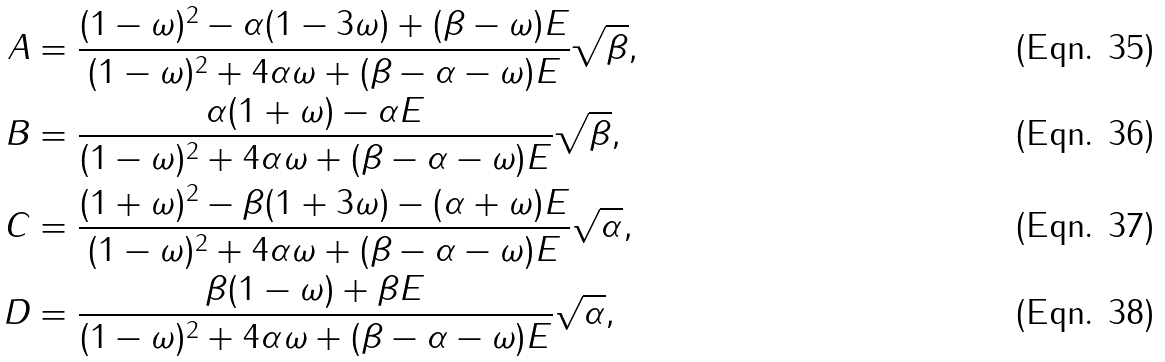Convert formula to latex. <formula><loc_0><loc_0><loc_500><loc_500>A & = \frac { ( 1 - \omega ) ^ { 2 } - \alpha ( 1 - 3 \omega ) + ( \beta - \omega ) E } { ( 1 - \omega ) ^ { 2 } + 4 \alpha \omega + ( \beta - \alpha - \omega ) E } \sqrt { \beta } , \\ B & = \frac { \alpha ( 1 + \omega ) - \alpha E } { ( 1 - \omega ) ^ { 2 } + 4 \alpha \omega + ( \beta - \alpha - \omega ) E } \sqrt { \beta } , \\ C & = \frac { ( 1 + \omega ) ^ { 2 } - \beta ( 1 + 3 \omega ) - ( \alpha + \omega ) E } { ( 1 - \omega ) ^ { 2 } + 4 \alpha \omega + ( \beta - \alpha - \omega ) E } \sqrt { \alpha } , \\ D & = \frac { \beta ( 1 - \omega ) + \beta E } { ( 1 - \omega ) ^ { 2 } + 4 \alpha \omega + ( \beta - \alpha - \omega ) E } \sqrt { \alpha } ,</formula> 